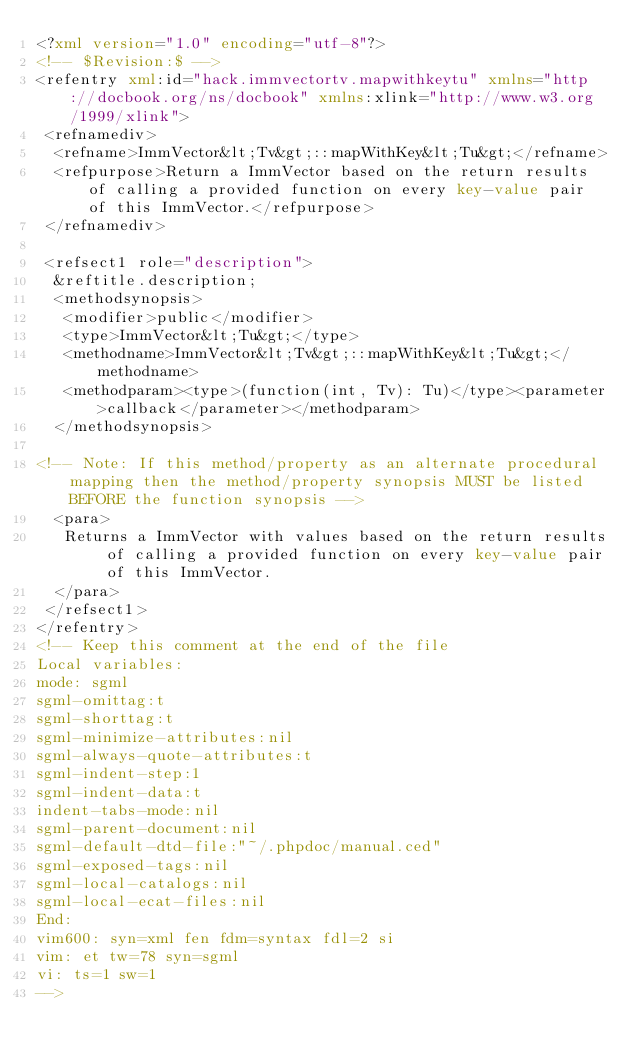<code> <loc_0><loc_0><loc_500><loc_500><_XML_><?xml version="1.0" encoding="utf-8"?>
<!-- $Revision:$ -->
<refentry xml:id="hack.immvectortv.mapwithkeytu" xmlns="http://docbook.org/ns/docbook" xmlns:xlink="http://www.w3.org/1999/xlink">
 <refnamediv>
  <refname>ImmVector&lt;Tv&gt;::mapWithKey&lt;Tu&gt;</refname>
  <refpurpose>Return a ImmVector based on the return results of calling a provided function on every key-value pair of this ImmVector.</refpurpose>
 </refnamediv>

 <refsect1 role="description">
  &reftitle.description;
  <methodsynopsis>
   <modifier>public</modifier>
   <type>ImmVector&lt;Tu&gt;</type>
   <methodname>ImmVector&lt;Tv&gt;::mapWithKey&lt;Tu&gt;</methodname>
   <methodparam><type>(function(int, Tv): Tu)</type><parameter>callback</parameter></methodparam>
  </methodsynopsis>

<!-- Note: If this method/property as an alternate procedural mapping then the method/property synopsis MUST be listed BEFORE the function synopsis -->
  <para>
   Returns a ImmVector with values based on the return results of calling a provided function on every key-value pair of this ImmVector.
  </para>
 </refsect1>
</refentry>
<!-- Keep this comment at the end of the file
Local variables:
mode: sgml
sgml-omittag:t
sgml-shorttag:t
sgml-minimize-attributes:nil
sgml-always-quote-attributes:t
sgml-indent-step:1
sgml-indent-data:t
indent-tabs-mode:nil
sgml-parent-document:nil
sgml-default-dtd-file:"~/.phpdoc/manual.ced"
sgml-exposed-tags:nil
sgml-local-catalogs:nil
sgml-local-ecat-files:nil
End:
vim600: syn=xml fen fdm=syntax fdl=2 si
vim: et tw=78 syn=sgml
vi: ts=1 sw=1
-->
</code> 